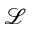<formula> <loc_0><loc_0><loc_500><loc_500>\mathcal { L }</formula> 